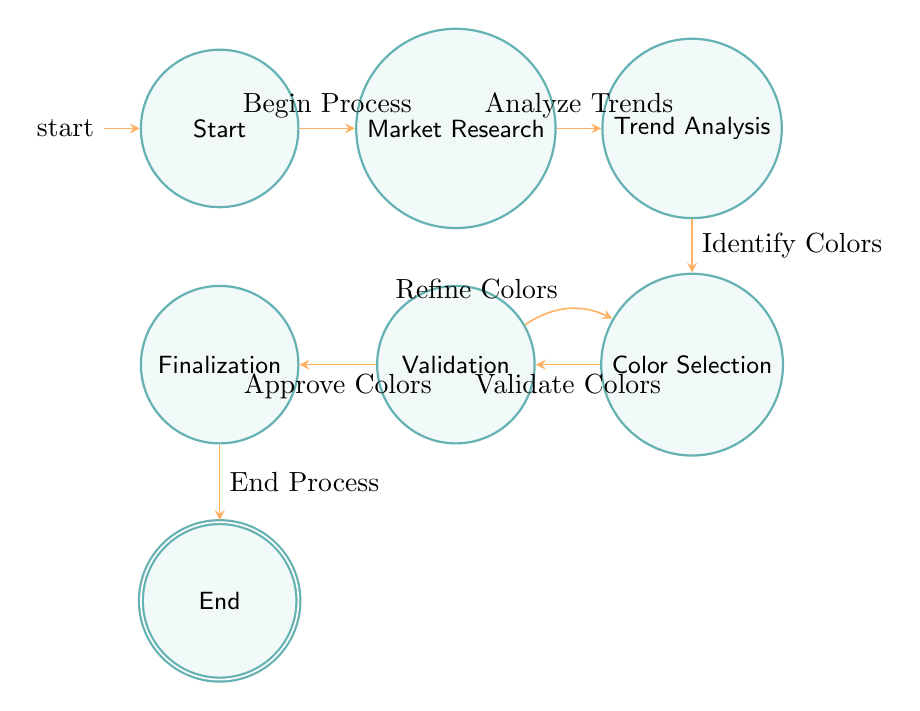What is the starting point of the process? The starting point is indicated as the "Start" node in the diagram, which is the first state that the process begins from.
Answer: Start How many states are in the diagram? By counting each labeled state in the diagram, we find there are six unique states: Start, Market Research, Trend Analysis, Color Selection, Validation, Finalization, and End, totaling seven states.
Answer: Seven What transition occurs after "Market Research"? According to the diagram, after "Market Research," the next transition is to "Trend Analysis," triggered by the input "Analyze Trends."
Answer: Trend Analysis Which state follows "Validation" if colors are approved? When colors are approved in the "Validation" state, the next state according to the diagram is "Finalization," as indicated by the transition "Approve Colors."
Answer: Finalization How can one return to "Color Selection" from "Validation"? To return to "Color Selection," the input "Refine Colors" is necessary, which allows for looping back to the "Color Selection" state from the "Validation" state.
Answer: Refine Colors What is the final state of the process? The final state of the process, indicated at the bottom of the diagram, is "End," which signifies the completion of the process after "Finalization."
Answer: End What is the input leading from "Color Selection" to "Validation"? From "Color Selection" to "Validation," the input required is "Validate Colors," which signifies the transition to the next state.
Answer: Validate Colors What happens if the colors are not approved during validation? If the colors are not approved during "Validation," one must refine the colors, resulting in a transition back to "Color Selection," as indicated by the input option "Refine Colors."
Answer: Refine Colors 